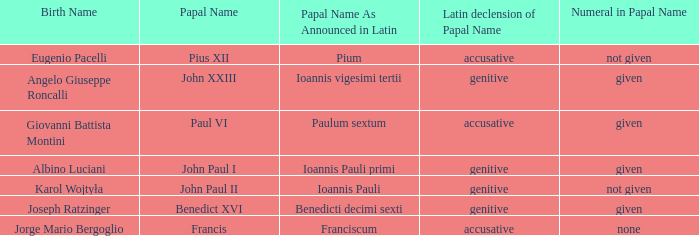For Pope Paul VI, what is the declension of his papal name? Accusative. 